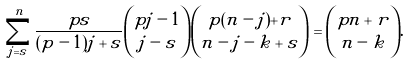Convert formula to latex. <formula><loc_0><loc_0><loc_500><loc_500>\sum _ { j = s } ^ { n } \frac { p s } { ( p - 1 ) j + s } \binom { p j - 1 } { j - s } \binom { p ( n - j ) + r } { n - j - k + s } = \binom { p n + r } { n - k } .</formula> 